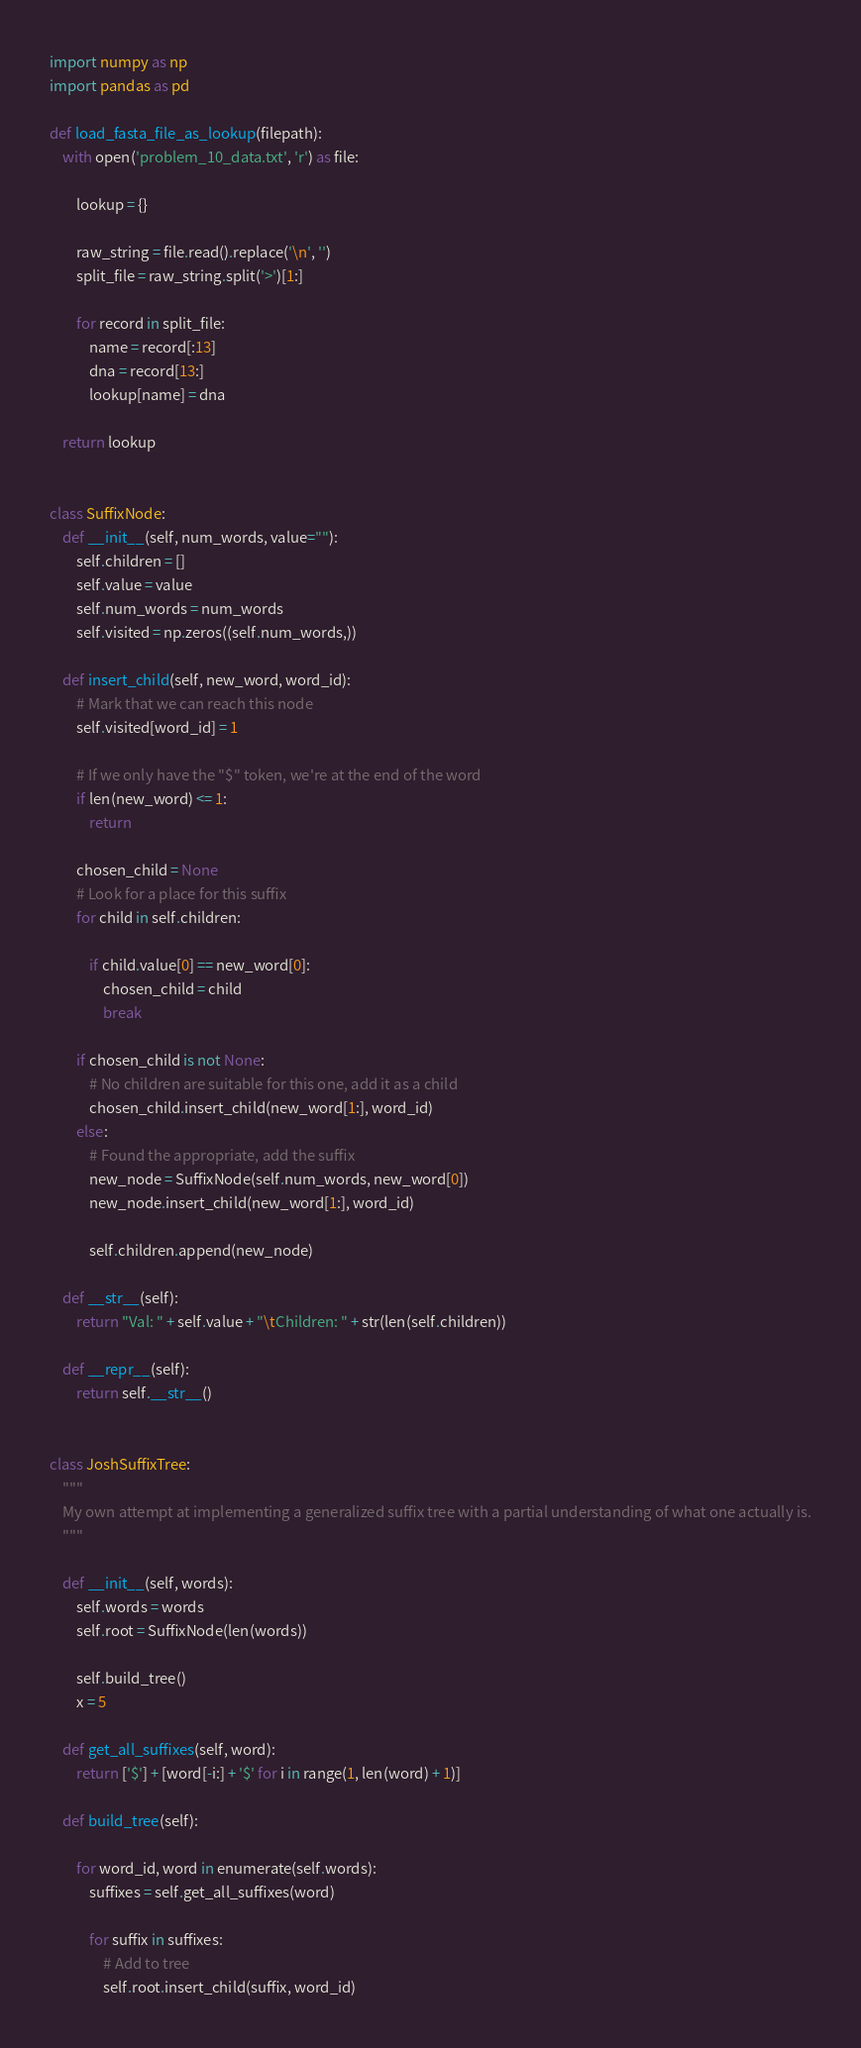<code> <loc_0><loc_0><loc_500><loc_500><_Python_>import numpy as np
import pandas as pd

def load_fasta_file_as_lookup(filepath):
    with open('problem_10_data.txt', 'r') as file:

        lookup = {}

        raw_string = file.read().replace('\n', '')
        split_file = raw_string.split('>')[1:]

        for record in split_file:
            name = record[:13]
            dna = record[13:]
            lookup[name] = dna

    return lookup


class SuffixNode:
    def __init__(self, num_words, value=""):
        self.children = []
        self.value = value
        self.num_words = num_words
        self.visited = np.zeros((self.num_words,))

    def insert_child(self, new_word, word_id):
        # Mark that we can reach this node
        self.visited[word_id] = 1

        # If we only have the "$" token, we're at the end of the word
        if len(new_word) <= 1:
            return

        chosen_child = None
        # Look for a place for this suffix
        for child in self.children:

            if child.value[0] == new_word[0]:
                chosen_child = child
                break

        if chosen_child is not None:
            # No children are suitable for this one, add it as a child
            chosen_child.insert_child(new_word[1:], word_id)
        else:
            # Found the appropriate, add the suffix
            new_node = SuffixNode(self.num_words, new_word[0])
            new_node.insert_child(new_word[1:], word_id)

            self.children.append(new_node)

    def __str__(self):
        return "Val: " + self.value + "\tChildren: " + str(len(self.children))

    def __repr__(self):
        return self.__str__()


class JoshSuffixTree:
    """
    My own attempt at implementing a generalized suffix tree with a partial understanding of what one actually is.
    """

    def __init__(self, words):
        self.words = words
        self.root = SuffixNode(len(words))

        self.build_tree()
        x = 5

    def get_all_suffixes(self, word):
        return ['$'] + [word[-i:] + '$' for i in range(1, len(word) + 1)]

    def build_tree(self):

        for word_id, word in enumerate(self.words):
            suffixes = self.get_all_suffixes(word)

            for suffix in suffixes:
                # Add to tree
                self.root.insert_child(suffix, word_id)
</code> 